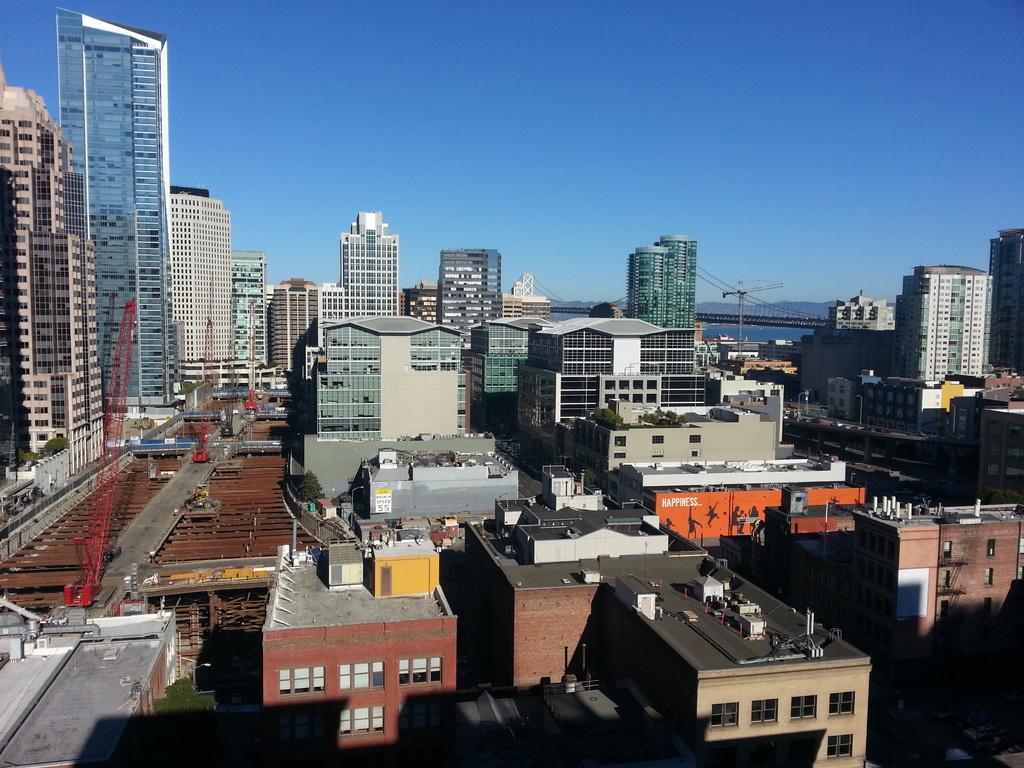Can you describe this image briefly? In this image there are so many buildings, at the back there is a mountain. 